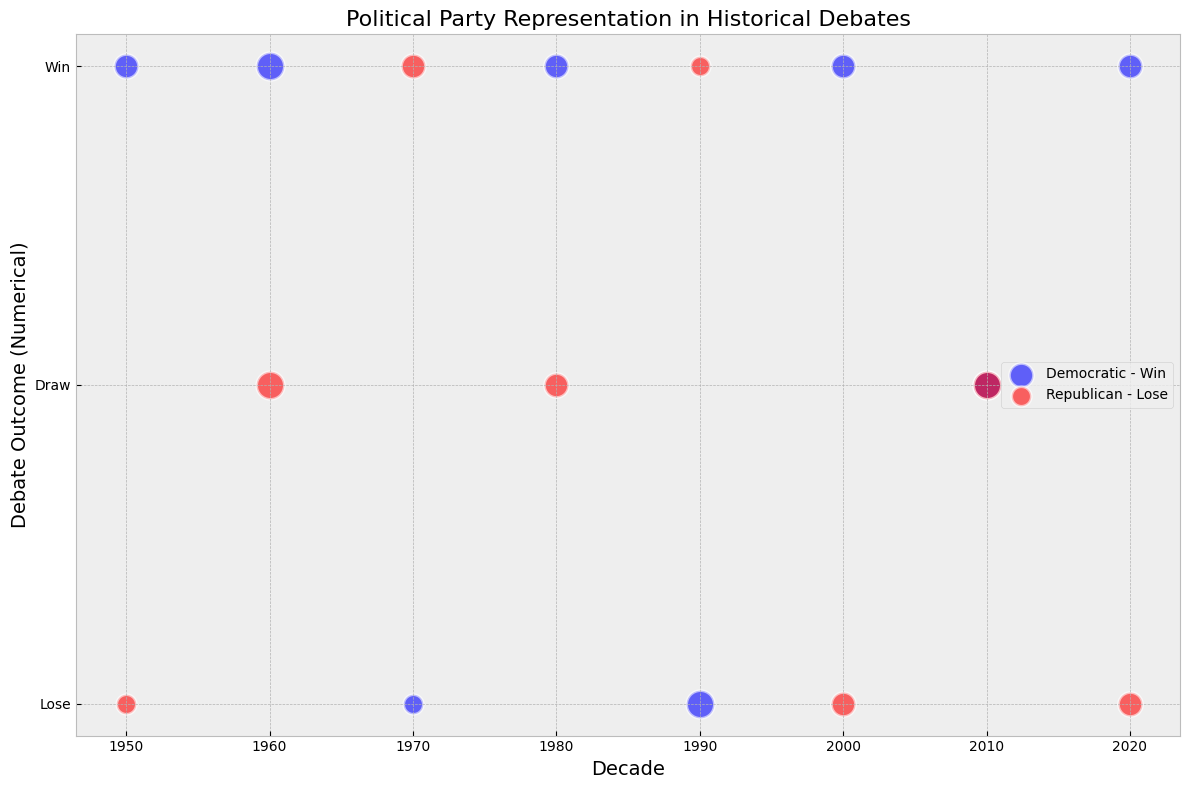Which decade had the most debate outcomes categorized as a 'Draw'? By looking at the visual markers (specifically, the squares) on the y-axis at 'Draw (0)', we see that the 2010s had the largest number of squares, representing both Democratic and Republican draws.
Answer: 2010s Compare the number of participants in debates during the 1960s for both Democratic and Republican parties. Which party had more participants? Look at the size of the bubbles for the 1960s. Democratic bubbles are noticeably larger compared to Republican bubbles, indicating more debate participants for the Democratic party.
Answer: Democratic Which political party had more frequent wins across all decades? Observe the blue and red bubbles at the '1' level on the y-axis, denoting wins. The Democratic (blue) bubbles appear more frequently than Republican (red) bubbles at this level.
Answer: Democratic How many decades feature debates with an equal number of participants from both parties? Identify the decades where the bubbles corresponding to both Democratic and Republican parties have the same size. For the 1960s and 2010s, both parties have the same number (4 and 4 participants respectively).
Answer: 2 decades In which decade did Republicans achieve their first win? The first red bubble at the '1' on the y-axis corresponds to the 1970s. This indicates the first decade where the Republican party won a debate.
Answer: 1970s Comparing the 2000s and 2020s, which decade had Democratic victories with fewer participants? Look at the size of the blue bubbles at the '1' index (wins) for both decades. The size is smaller in the 2020s than in the 2000s, indicating fewer participants.
Answer: 2020s Across all decades, which political party had the largest single debate in terms of the number of participants? Identify the largest bubble in terms of diameter. The Democratic bubble in the 1960s is the largest, representing the highest number of participants (four).
Answer: Democratic When did the Democratic party experience a loss with the smallest number of participants? Look at the smallest blue bubbles located at the '-1' index. The decade corresponding to this is the 1970s, where the Democratic party had two participants and lost.
Answer: 1970s In which decade did both parties have an equal number of wins? Observe the number of red and blue bubbles at the '1' level in each decade. The 1980s had an equal number of wins for both parties, with one win each.
Answer: 1980s 